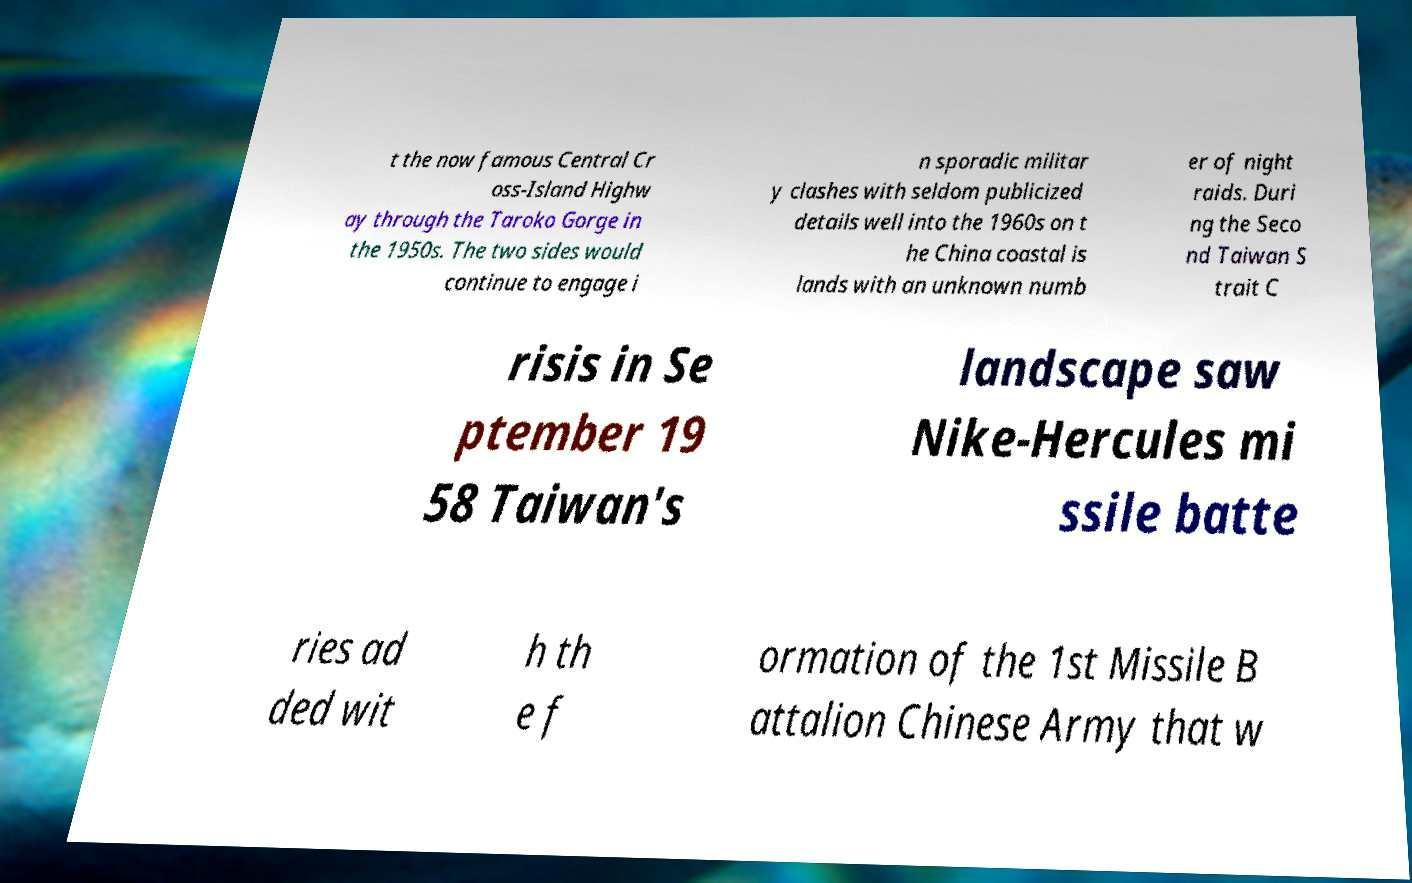For documentation purposes, I need the text within this image transcribed. Could you provide that? t the now famous Central Cr oss-Island Highw ay through the Taroko Gorge in the 1950s. The two sides would continue to engage i n sporadic militar y clashes with seldom publicized details well into the 1960s on t he China coastal is lands with an unknown numb er of night raids. Duri ng the Seco nd Taiwan S trait C risis in Se ptember 19 58 Taiwan's landscape saw Nike-Hercules mi ssile batte ries ad ded wit h th e f ormation of the 1st Missile B attalion Chinese Army that w 